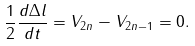<formula> <loc_0><loc_0><loc_500><loc_500>\frac { 1 } { 2 } \frac { d \Delta l } { d t } = V _ { 2 n } - V _ { 2 n - 1 } = 0 .</formula> 